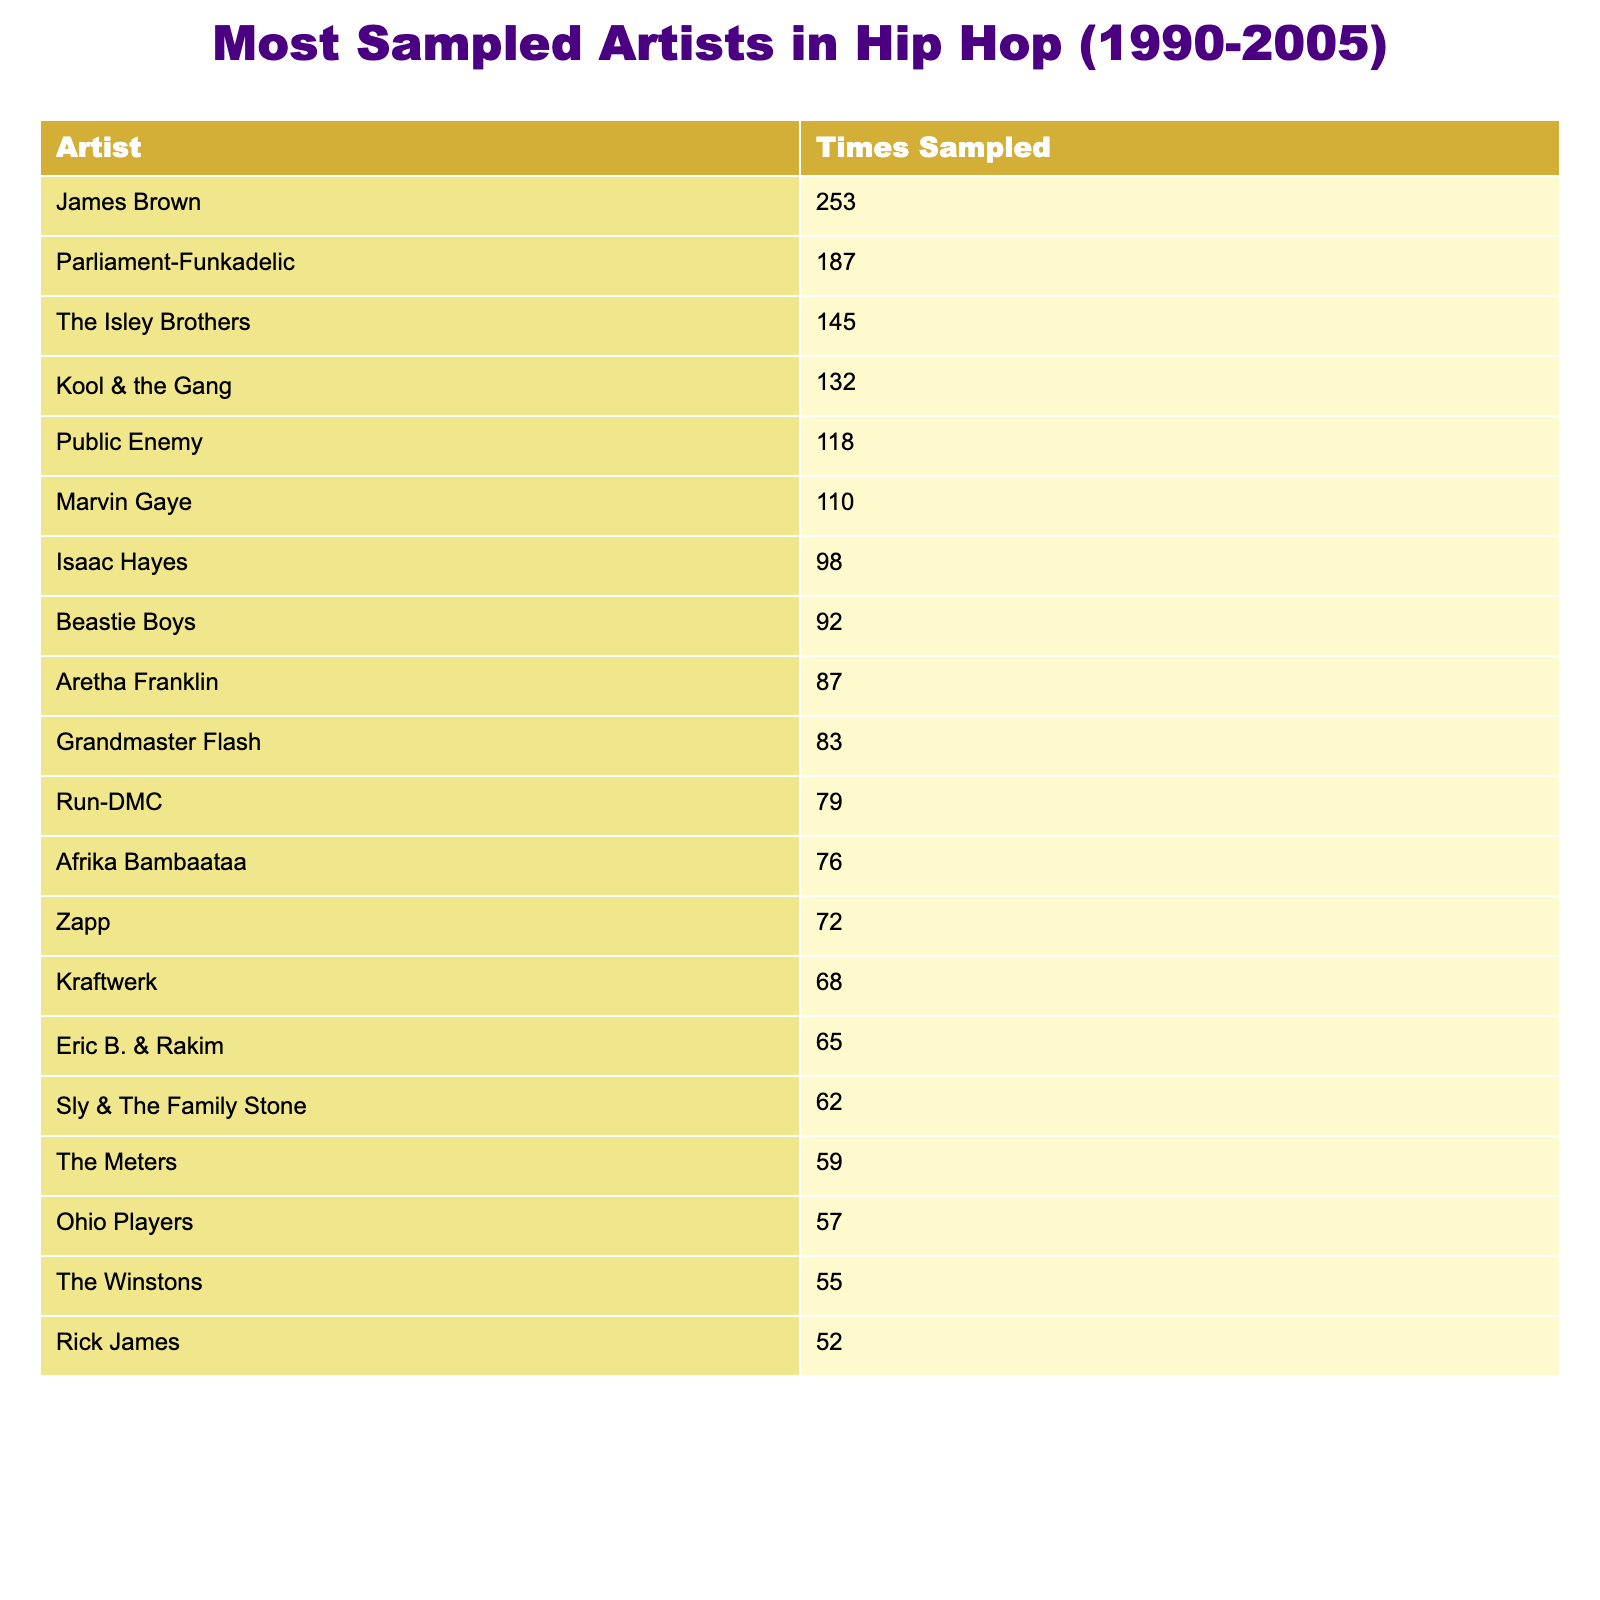What artist is sampled the most in hip hop from 1990 to 2005? The table shows that James Brown has been sampled the most with a total of 253 times.
Answer: James Brown What is the total number of times the top three sampled artists were sampled? To find this, add the numbers for James Brown (253), Parliament-Funkadelic (187), and The Isley Brothers (145). This results in 253 + 187 + 145 = 585.
Answer: 585 Which artist has been sampled the least among the top ten? Looking at the top ten artists, Grandmaster Flash has been sampled 83 times, which is the lowest in that range.
Answer: Grandmaster Flash Is Marvin Gaye among the top five most sampled artists? Yes, Marvin Gaye is listed with a total of 110 samples, placing him in the top five of the list.
Answer: Yes How many more times was Parliament-Funkadelic sampled than Marvin Gaye? The difference is calculated by subtracting Marvin Gaye's total (110) from Parliament-Funkadelic's total (187), which gives 187 - 110 = 77.
Answer: 77 What percent of samples do James Brown and The Isley Brothers make up of the total samples by the top ten artists? First, calculate the total for the top ten, which is 253 + 187 + 145 + 132 + 118 + 110 + 98 + 92 + 87 + 83 = 1,305. Then sum James Brown and The Isley Brothers: 253 + 145 = 398. The percentage is calculated as (398 / 1,305) * 100 ≈ 30.5%.
Answer: Approximately 30.5% Which artist has a sampling count that is a multiple of ten? By reviewing the table, artists with counts that are multiples of ten include James Brown (253), Parliament-Funkadelic (187), The Isley Brothers (145), Kool & the Gang (132), and others as well, confirming their values.
Answer: Yes What is the average sampling count of the top ten artists? To find the average, sum the sampling counts: 253 + 187 + 145 + 132 + 118 + 110 + 98 + 92 + 87 + 83 = 1,305 and divide by ten (10) which gives 1,305 / 10 = 130.5.
Answer: 130.5 Which two artists have a sampling count that combined is less than the least sampled artist in the top ten? The least sampled artist in the top ten is Grandmaster Flash (83). Checking combinations, Zapp (72) and Afrika Bambaataa (76) add up to 148, which is not less, but Grandmaster Flash (83) and Rick James (52) sum to 135, which also is more. Therefore, these pairs yield no valid combinations under 83.
Answer: No valid combinations How many artists have been sampled more than 100 times? By reviewing the table, these artists are James Brown, Parliament-Funkadelic, The Isley Brothers, Kool & the Gang, Public Enemy, Marvin Gaye, and Isaac Hayes. Counting these confirms seven artists exceed 100.
Answer: 7 